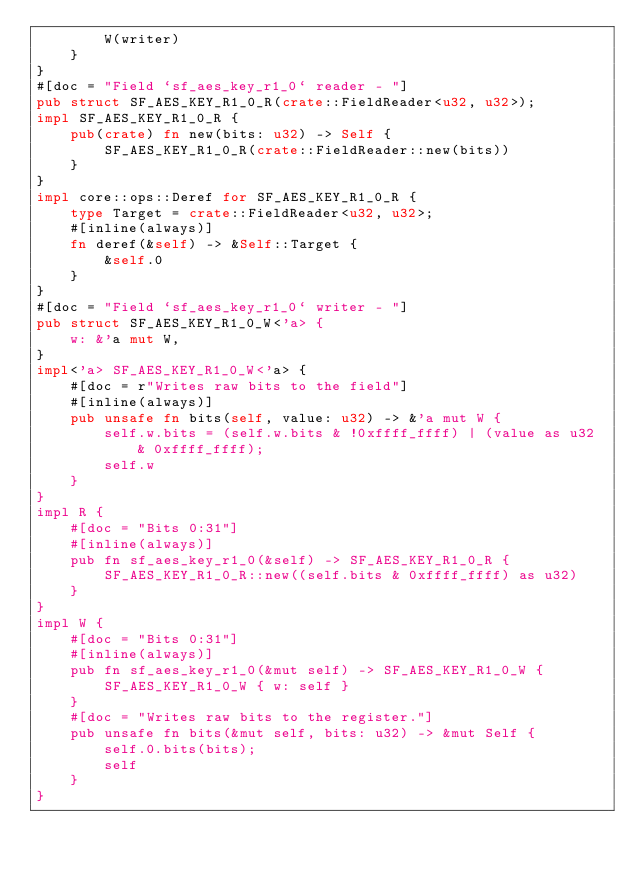Convert code to text. <code><loc_0><loc_0><loc_500><loc_500><_Rust_>        W(writer)
    }
}
#[doc = "Field `sf_aes_key_r1_0` reader - "]
pub struct SF_AES_KEY_R1_0_R(crate::FieldReader<u32, u32>);
impl SF_AES_KEY_R1_0_R {
    pub(crate) fn new(bits: u32) -> Self {
        SF_AES_KEY_R1_0_R(crate::FieldReader::new(bits))
    }
}
impl core::ops::Deref for SF_AES_KEY_R1_0_R {
    type Target = crate::FieldReader<u32, u32>;
    #[inline(always)]
    fn deref(&self) -> &Self::Target {
        &self.0
    }
}
#[doc = "Field `sf_aes_key_r1_0` writer - "]
pub struct SF_AES_KEY_R1_0_W<'a> {
    w: &'a mut W,
}
impl<'a> SF_AES_KEY_R1_0_W<'a> {
    #[doc = r"Writes raw bits to the field"]
    #[inline(always)]
    pub unsafe fn bits(self, value: u32) -> &'a mut W {
        self.w.bits = (self.w.bits & !0xffff_ffff) | (value as u32 & 0xffff_ffff);
        self.w
    }
}
impl R {
    #[doc = "Bits 0:31"]
    #[inline(always)]
    pub fn sf_aes_key_r1_0(&self) -> SF_AES_KEY_R1_0_R {
        SF_AES_KEY_R1_0_R::new((self.bits & 0xffff_ffff) as u32)
    }
}
impl W {
    #[doc = "Bits 0:31"]
    #[inline(always)]
    pub fn sf_aes_key_r1_0(&mut self) -> SF_AES_KEY_R1_0_W {
        SF_AES_KEY_R1_0_W { w: self }
    }
    #[doc = "Writes raw bits to the register."]
    pub unsafe fn bits(&mut self, bits: u32) -> &mut Self {
        self.0.bits(bits);
        self
    }
}</code> 